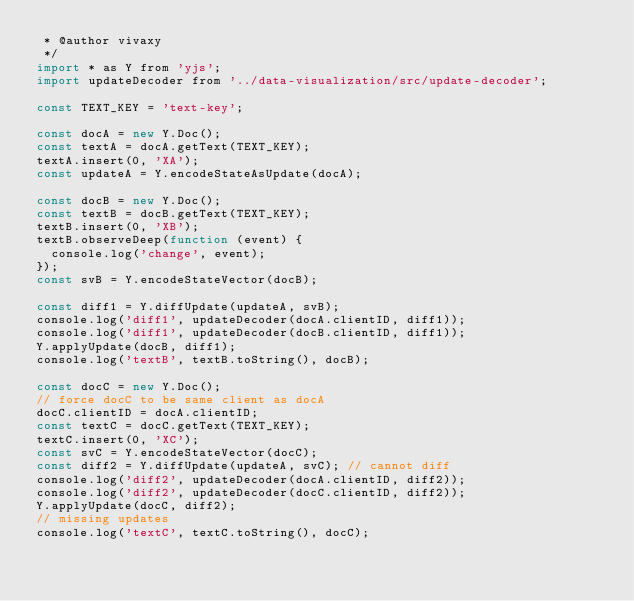Convert code to text. <code><loc_0><loc_0><loc_500><loc_500><_JavaScript_> * @author vivaxy
 */
import * as Y from 'yjs';
import updateDecoder from '../data-visualization/src/update-decoder';

const TEXT_KEY = 'text-key';

const docA = new Y.Doc();
const textA = docA.getText(TEXT_KEY);
textA.insert(0, 'XA');
const updateA = Y.encodeStateAsUpdate(docA);

const docB = new Y.Doc();
const textB = docB.getText(TEXT_KEY);
textB.insert(0, 'XB');
textB.observeDeep(function (event) {
  console.log('change', event);
});
const svB = Y.encodeStateVector(docB);

const diff1 = Y.diffUpdate(updateA, svB);
console.log('diff1', updateDecoder(docA.clientID, diff1));
console.log('diff1', updateDecoder(docB.clientID, diff1));
Y.applyUpdate(docB, diff1);
console.log('textB', textB.toString(), docB);

const docC = new Y.Doc();
// force docC to be same client as docA
docC.clientID = docA.clientID;
const textC = docC.getText(TEXT_KEY);
textC.insert(0, 'XC');
const svC = Y.encodeStateVector(docC);
const diff2 = Y.diffUpdate(updateA, svC); // cannot diff
console.log('diff2', updateDecoder(docA.clientID, diff2));
console.log('diff2', updateDecoder(docC.clientID, diff2));
Y.applyUpdate(docC, diff2);
// missing updates
console.log('textC', textC.toString(), docC);
</code> 